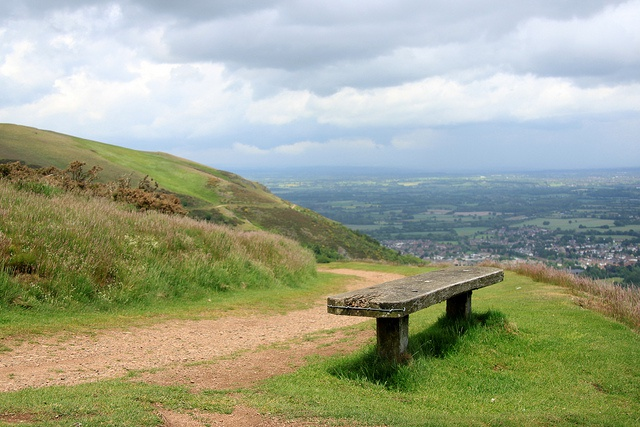Describe the objects in this image and their specific colors. I can see a bench in lightblue, black, tan, and darkgreen tones in this image. 